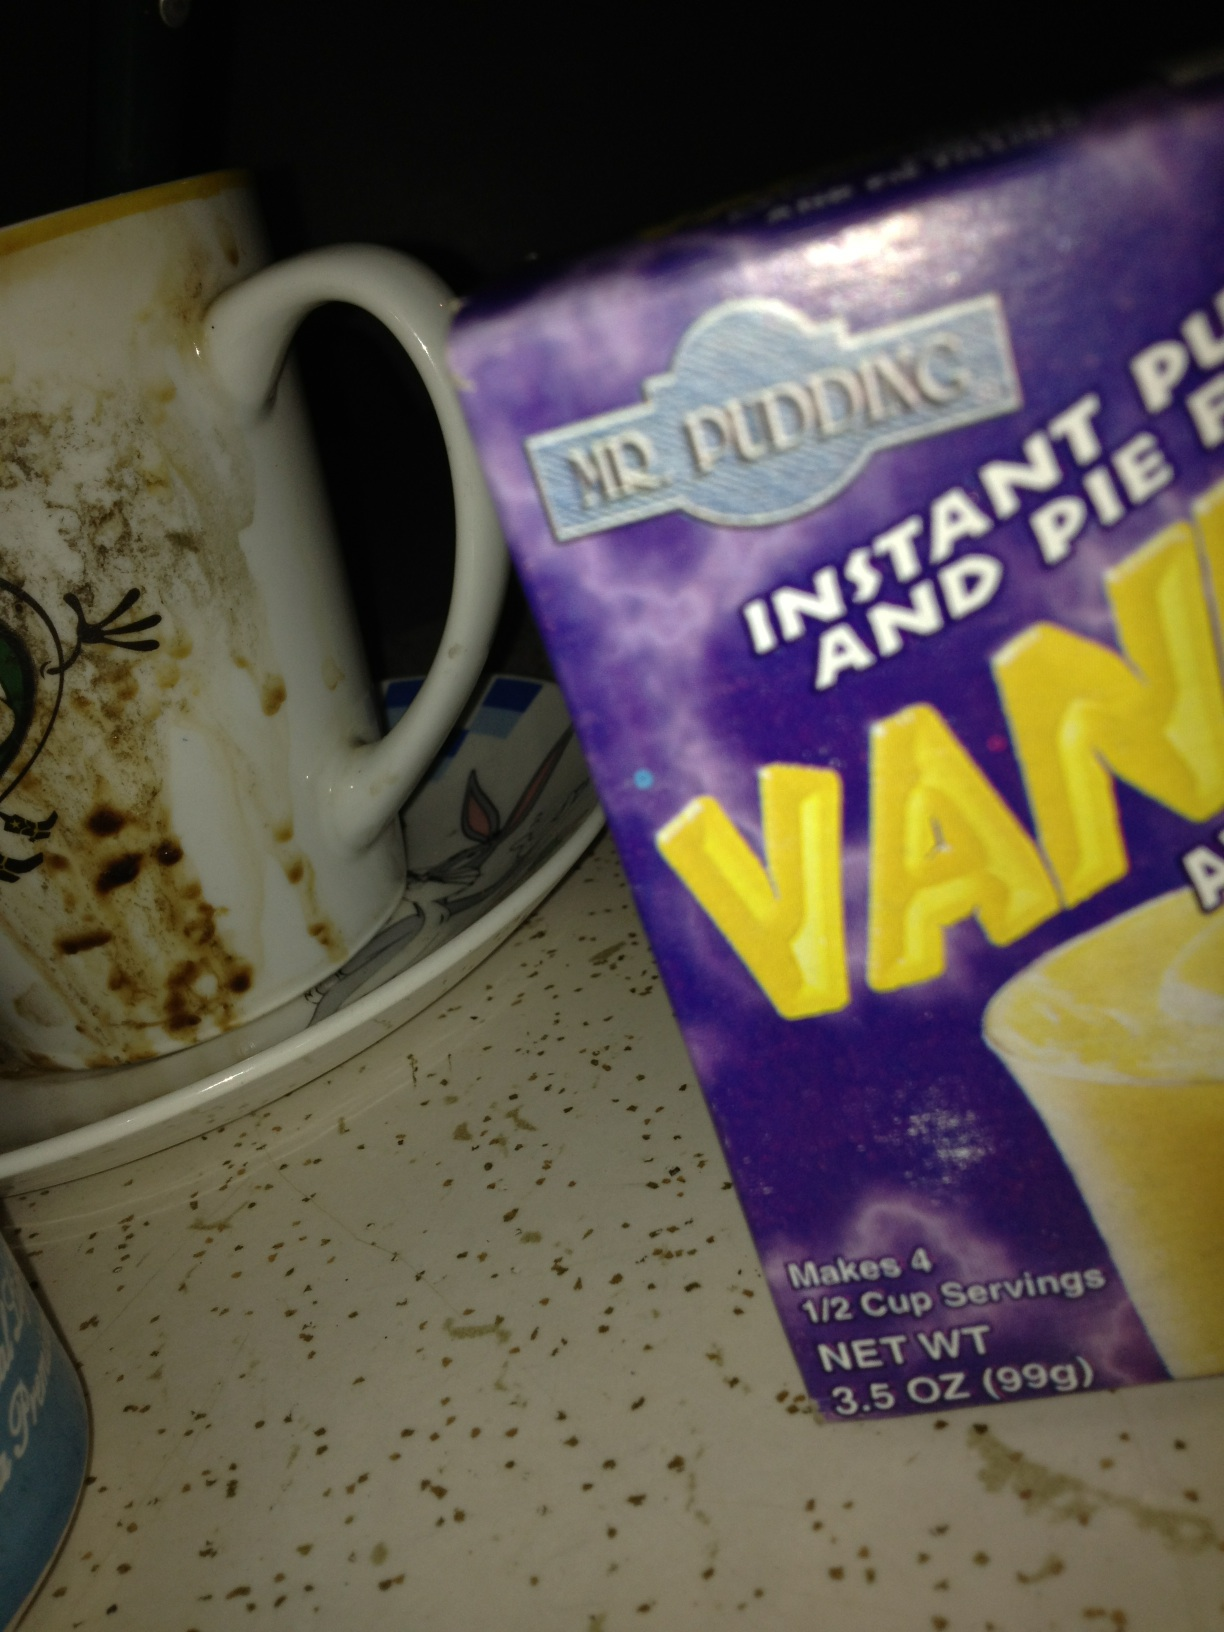What ingredients might be needed to prepare this pudding? To prepare a typical instant pudding you would generally need cold milk. Specific instructions for 'Mr. Pudding' mix would be on the box, detailing the exact amount of milk and any additional steps. 